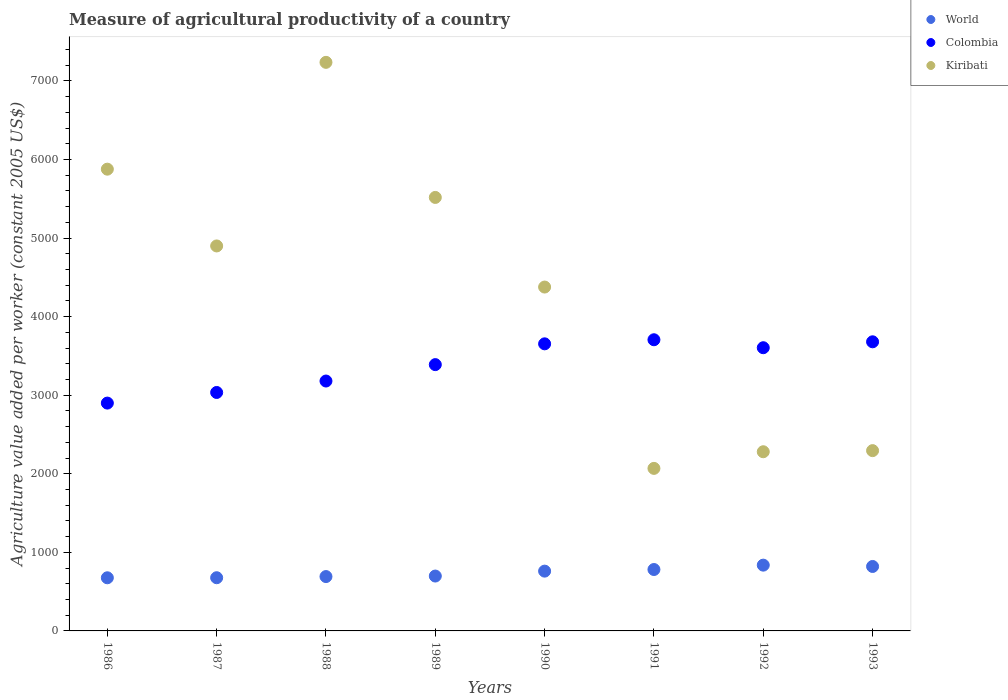What is the measure of agricultural productivity in Kiribati in 1989?
Ensure brevity in your answer.  5517.42. Across all years, what is the maximum measure of agricultural productivity in Kiribati?
Offer a terse response. 7236.76. Across all years, what is the minimum measure of agricultural productivity in World?
Provide a succinct answer. 676.35. In which year was the measure of agricultural productivity in World maximum?
Your answer should be compact. 1992. In which year was the measure of agricultural productivity in World minimum?
Offer a very short reply. 1986. What is the total measure of agricultural productivity in Colombia in the graph?
Ensure brevity in your answer.  2.71e+04. What is the difference between the measure of agricultural productivity in Colombia in 1988 and that in 1989?
Provide a succinct answer. -208.86. What is the difference between the measure of agricultural productivity in World in 1986 and the measure of agricultural productivity in Kiribati in 1987?
Offer a very short reply. -4223.58. What is the average measure of agricultural productivity in Colombia per year?
Offer a terse response. 3393.66. In the year 1987, what is the difference between the measure of agricultural productivity in Colombia and measure of agricultural productivity in World?
Provide a succinct answer. 2357.88. What is the ratio of the measure of agricultural productivity in World in 1986 to that in 1990?
Give a very brief answer. 0.89. Is the measure of agricultural productivity in Colombia in 1991 less than that in 1993?
Provide a short and direct response. No. Is the difference between the measure of agricultural productivity in Colombia in 1988 and 1989 greater than the difference between the measure of agricultural productivity in World in 1988 and 1989?
Your answer should be compact. No. What is the difference between the highest and the second highest measure of agricultural productivity in World?
Make the answer very short. 16.9. What is the difference between the highest and the lowest measure of agricultural productivity in Kiribati?
Offer a terse response. 5168.02. In how many years, is the measure of agricultural productivity in World greater than the average measure of agricultural productivity in World taken over all years?
Provide a short and direct response. 4. Does the measure of agricultural productivity in World monotonically increase over the years?
Keep it short and to the point. No. Are the values on the major ticks of Y-axis written in scientific E-notation?
Provide a short and direct response. No. Where does the legend appear in the graph?
Provide a succinct answer. Top right. How many legend labels are there?
Provide a succinct answer. 3. How are the legend labels stacked?
Your answer should be compact. Vertical. What is the title of the graph?
Provide a short and direct response. Measure of agricultural productivity of a country. Does "Guam" appear as one of the legend labels in the graph?
Your answer should be very brief. No. What is the label or title of the Y-axis?
Offer a very short reply. Agriculture value added per worker (constant 2005 US$). What is the Agriculture value added per worker (constant 2005 US$) in World in 1986?
Offer a terse response. 676.35. What is the Agriculture value added per worker (constant 2005 US$) in Colombia in 1986?
Ensure brevity in your answer.  2899.8. What is the Agriculture value added per worker (constant 2005 US$) in Kiribati in 1986?
Your response must be concise. 5877.11. What is the Agriculture value added per worker (constant 2005 US$) of World in 1987?
Provide a short and direct response. 677.1. What is the Agriculture value added per worker (constant 2005 US$) of Colombia in 1987?
Your answer should be compact. 3034.98. What is the Agriculture value added per worker (constant 2005 US$) in Kiribati in 1987?
Offer a very short reply. 4899.93. What is the Agriculture value added per worker (constant 2005 US$) of World in 1988?
Offer a very short reply. 691.86. What is the Agriculture value added per worker (constant 2005 US$) of Colombia in 1988?
Give a very brief answer. 3180.59. What is the Agriculture value added per worker (constant 2005 US$) in Kiribati in 1988?
Provide a short and direct response. 7236.76. What is the Agriculture value added per worker (constant 2005 US$) of World in 1989?
Keep it short and to the point. 698.44. What is the Agriculture value added per worker (constant 2005 US$) of Colombia in 1989?
Make the answer very short. 3389.44. What is the Agriculture value added per worker (constant 2005 US$) of Kiribati in 1989?
Your answer should be very brief. 5517.42. What is the Agriculture value added per worker (constant 2005 US$) of World in 1990?
Make the answer very short. 761.04. What is the Agriculture value added per worker (constant 2005 US$) in Colombia in 1990?
Make the answer very short. 3654.06. What is the Agriculture value added per worker (constant 2005 US$) in Kiribati in 1990?
Give a very brief answer. 4376.7. What is the Agriculture value added per worker (constant 2005 US$) of World in 1991?
Offer a very short reply. 781.57. What is the Agriculture value added per worker (constant 2005 US$) of Colombia in 1991?
Keep it short and to the point. 3705.97. What is the Agriculture value added per worker (constant 2005 US$) in Kiribati in 1991?
Provide a succinct answer. 2068.74. What is the Agriculture value added per worker (constant 2005 US$) of World in 1992?
Offer a very short reply. 837.24. What is the Agriculture value added per worker (constant 2005 US$) in Colombia in 1992?
Offer a very short reply. 3604.59. What is the Agriculture value added per worker (constant 2005 US$) in Kiribati in 1992?
Offer a terse response. 2280.57. What is the Agriculture value added per worker (constant 2005 US$) in World in 1993?
Offer a very short reply. 820.33. What is the Agriculture value added per worker (constant 2005 US$) in Colombia in 1993?
Your response must be concise. 3679.85. What is the Agriculture value added per worker (constant 2005 US$) in Kiribati in 1993?
Provide a succinct answer. 2294.68. Across all years, what is the maximum Agriculture value added per worker (constant 2005 US$) in World?
Your response must be concise. 837.24. Across all years, what is the maximum Agriculture value added per worker (constant 2005 US$) of Colombia?
Your answer should be very brief. 3705.97. Across all years, what is the maximum Agriculture value added per worker (constant 2005 US$) of Kiribati?
Offer a very short reply. 7236.76. Across all years, what is the minimum Agriculture value added per worker (constant 2005 US$) in World?
Offer a terse response. 676.35. Across all years, what is the minimum Agriculture value added per worker (constant 2005 US$) in Colombia?
Give a very brief answer. 2899.8. Across all years, what is the minimum Agriculture value added per worker (constant 2005 US$) of Kiribati?
Offer a very short reply. 2068.74. What is the total Agriculture value added per worker (constant 2005 US$) in World in the graph?
Provide a succinct answer. 5943.93. What is the total Agriculture value added per worker (constant 2005 US$) of Colombia in the graph?
Ensure brevity in your answer.  2.71e+04. What is the total Agriculture value added per worker (constant 2005 US$) of Kiribati in the graph?
Provide a succinct answer. 3.46e+04. What is the difference between the Agriculture value added per worker (constant 2005 US$) in World in 1986 and that in 1987?
Offer a very short reply. -0.75. What is the difference between the Agriculture value added per worker (constant 2005 US$) in Colombia in 1986 and that in 1987?
Provide a succinct answer. -135.18. What is the difference between the Agriculture value added per worker (constant 2005 US$) in Kiribati in 1986 and that in 1987?
Offer a terse response. 977.19. What is the difference between the Agriculture value added per worker (constant 2005 US$) in World in 1986 and that in 1988?
Your response must be concise. -15.51. What is the difference between the Agriculture value added per worker (constant 2005 US$) of Colombia in 1986 and that in 1988?
Offer a terse response. -280.79. What is the difference between the Agriculture value added per worker (constant 2005 US$) of Kiribati in 1986 and that in 1988?
Provide a short and direct response. -1359.65. What is the difference between the Agriculture value added per worker (constant 2005 US$) of World in 1986 and that in 1989?
Offer a terse response. -22.09. What is the difference between the Agriculture value added per worker (constant 2005 US$) in Colombia in 1986 and that in 1989?
Your response must be concise. -489.64. What is the difference between the Agriculture value added per worker (constant 2005 US$) of Kiribati in 1986 and that in 1989?
Your response must be concise. 359.69. What is the difference between the Agriculture value added per worker (constant 2005 US$) of World in 1986 and that in 1990?
Your response must be concise. -84.69. What is the difference between the Agriculture value added per worker (constant 2005 US$) in Colombia in 1986 and that in 1990?
Your answer should be compact. -754.26. What is the difference between the Agriculture value added per worker (constant 2005 US$) in Kiribati in 1986 and that in 1990?
Your answer should be compact. 1500.41. What is the difference between the Agriculture value added per worker (constant 2005 US$) in World in 1986 and that in 1991?
Offer a very short reply. -105.22. What is the difference between the Agriculture value added per worker (constant 2005 US$) of Colombia in 1986 and that in 1991?
Provide a short and direct response. -806.17. What is the difference between the Agriculture value added per worker (constant 2005 US$) in Kiribati in 1986 and that in 1991?
Provide a succinct answer. 3808.37. What is the difference between the Agriculture value added per worker (constant 2005 US$) in World in 1986 and that in 1992?
Provide a short and direct response. -160.89. What is the difference between the Agriculture value added per worker (constant 2005 US$) of Colombia in 1986 and that in 1992?
Give a very brief answer. -704.79. What is the difference between the Agriculture value added per worker (constant 2005 US$) of Kiribati in 1986 and that in 1992?
Offer a very short reply. 3596.54. What is the difference between the Agriculture value added per worker (constant 2005 US$) in World in 1986 and that in 1993?
Make the answer very short. -143.98. What is the difference between the Agriculture value added per worker (constant 2005 US$) of Colombia in 1986 and that in 1993?
Your response must be concise. -780.05. What is the difference between the Agriculture value added per worker (constant 2005 US$) of Kiribati in 1986 and that in 1993?
Your answer should be very brief. 3582.43. What is the difference between the Agriculture value added per worker (constant 2005 US$) in World in 1987 and that in 1988?
Keep it short and to the point. -14.76. What is the difference between the Agriculture value added per worker (constant 2005 US$) of Colombia in 1987 and that in 1988?
Your response must be concise. -145.61. What is the difference between the Agriculture value added per worker (constant 2005 US$) in Kiribati in 1987 and that in 1988?
Your answer should be compact. -2336.83. What is the difference between the Agriculture value added per worker (constant 2005 US$) of World in 1987 and that in 1989?
Your answer should be compact. -21.34. What is the difference between the Agriculture value added per worker (constant 2005 US$) of Colombia in 1987 and that in 1989?
Your answer should be compact. -354.46. What is the difference between the Agriculture value added per worker (constant 2005 US$) in Kiribati in 1987 and that in 1989?
Your response must be concise. -617.5. What is the difference between the Agriculture value added per worker (constant 2005 US$) of World in 1987 and that in 1990?
Ensure brevity in your answer.  -83.94. What is the difference between the Agriculture value added per worker (constant 2005 US$) of Colombia in 1987 and that in 1990?
Give a very brief answer. -619.08. What is the difference between the Agriculture value added per worker (constant 2005 US$) in Kiribati in 1987 and that in 1990?
Provide a short and direct response. 523.22. What is the difference between the Agriculture value added per worker (constant 2005 US$) of World in 1987 and that in 1991?
Offer a very short reply. -104.47. What is the difference between the Agriculture value added per worker (constant 2005 US$) in Colombia in 1987 and that in 1991?
Keep it short and to the point. -670.99. What is the difference between the Agriculture value added per worker (constant 2005 US$) of Kiribati in 1987 and that in 1991?
Keep it short and to the point. 2831.18. What is the difference between the Agriculture value added per worker (constant 2005 US$) in World in 1987 and that in 1992?
Your answer should be very brief. -160.14. What is the difference between the Agriculture value added per worker (constant 2005 US$) in Colombia in 1987 and that in 1992?
Your answer should be very brief. -569.61. What is the difference between the Agriculture value added per worker (constant 2005 US$) of Kiribati in 1987 and that in 1992?
Provide a succinct answer. 2619.36. What is the difference between the Agriculture value added per worker (constant 2005 US$) of World in 1987 and that in 1993?
Your response must be concise. -143.24. What is the difference between the Agriculture value added per worker (constant 2005 US$) of Colombia in 1987 and that in 1993?
Your answer should be very brief. -644.87. What is the difference between the Agriculture value added per worker (constant 2005 US$) of Kiribati in 1987 and that in 1993?
Provide a succinct answer. 2605.25. What is the difference between the Agriculture value added per worker (constant 2005 US$) of World in 1988 and that in 1989?
Your answer should be very brief. -6.58. What is the difference between the Agriculture value added per worker (constant 2005 US$) in Colombia in 1988 and that in 1989?
Keep it short and to the point. -208.86. What is the difference between the Agriculture value added per worker (constant 2005 US$) in Kiribati in 1988 and that in 1989?
Provide a succinct answer. 1719.33. What is the difference between the Agriculture value added per worker (constant 2005 US$) in World in 1988 and that in 1990?
Provide a short and direct response. -69.18. What is the difference between the Agriculture value added per worker (constant 2005 US$) in Colombia in 1988 and that in 1990?
Your response must be concise. -473.48. What is the difference between the Agriculture value added per worker (constant 2005 US$) in Kiribati in 1988 and that in 1990?
Keep it short and to the point. 2860.06. What is the difference between the Agriculture value added per worker (constant 2005 US$) of World in 1988 and that in 1991?
Your answer should be compact. -89.71. What is the difference between the Agriculture value added per worker (constant 2005 US$) of Colombia in 1988 and that in 1991?
Keep it short and to the point. -525.39. What is the difference between the Agriculture value added per worker (constant 2005 US$) in Kiribati in 1988 and that in 1991?
Provide a succinct answer. 5168.02. What is the difference between the Agriculture value added per worker (constant 2005 US$) of World in 1988 and that in 1992?
Your response must be concise. -145.38. What is the difference between the Agriculture value added per worker (constant 2005 US$) in Colombia in 1988 and that in 1992?
Keep it short and to the point. -424. What is the difference between the Agriculture value added per worker (constant 2005 US$) of Kiribati in 1988 and that in 1992?
Your answer should be very brief. 4956.19. What is the difference between the Agriculture value added per worker (constant 2005 US$) in World in 1988 and that in 1993?
Ensure brevity in your answer.  -128.47. What is the difference between the Agriculture value added per worker (constant 2005 US$) in Colombia in 1988 and that in 1993?
Provide a short and direct response. -499.26. What is the difference between the Agriculture value added per worker (constant 2005 US$) of Kiribati in 1988 and that in 1993?
Provide a succinct answer. 4942.08. What is the difference between the Agriculture value added per worker (constant 2005 US$) in World in 1989 and that in 1990?
Your answer should be compact. -62.6. What is the difference between the Agriculture value added per worker (constant 2005 US$) in Colombia in 1989 and that in 1990?
Offer a terse response. -264.62. What is the difference between the Agriculture value added per worker (constant 2005 US$) of Kiribati in 1989 and that in 1990?
Offer a terse response. 1140.72. What is the difference between the Agriculture value added per worker (constant 2005 US$) of World in 1989 and that in 1991?
Provide a succinct answer. -83.13. What is the difference between the Agriculture value added per worker (constant 2005 US$) of Colombia in 1989 and that in 1991?
Your answer should be very brief. -316.53. What is the difference between the Agriculture value added per worker (constant 2005 US$) of Kiribati in 1989 and that in 1991?
Give a very brief answer. 3448.68. What is the difference between the Agriculture value added per worker (constant 2005 US$) in World in 1989 and that in 1992?
Your answer should be very brief. -138.8. What is the difference between the Agriculture value added per worker (constant 2005 US$) in Colombia in 1989 and that in 1992?
Provide a succinct answer. -215.14. What is the difference between the Agriculture value added per worker (constant 2005 US$) of Kiribati in 1989 and that in 1992?
Offer a very short reply. 3236.86. What is the difference between the Agriculture value added per worker (constant 2005 US$) of World in 1989 and that in 1993?
Make the answer very short. -121.89. What is the difference between the Agriculture value added per worker (constant 2005 US$) in Colombia in 1989 and that in 1993?
Provide a short and direct response. -290.4. What is the difference between the Agriculture value added per worker (constant 2005 US$) in Kiribati in 1989 and that in 1993?
Provide a short and direct response. 3222.75. What is the difference between the Agriculture value added per worker (constant 2005 US$) in World in 1990 and that in 1991?
Offer a very short reply. -20.53. What is the difference between the Agriculture value added per worker (constant 2005 US$) of Colombia in 1990 and that in 1991?
Provide a succinct answer. -51.91. What is the difference between the Agriculture value added per worker (constant 2005 US$) in Kiribati in 1990 and that in 1991?
Make the answer very short. 2307.96. What is the difference between the Agriculture value added per worker (constant 2005 US$) in World in 1990 and that in 1992?
Ensure brevity in your answer.  -76.2. What is the difference between the Agriculture value added per worker (constant 2005 US$) of Colombia in 1990 and that in 1992?
Make the answer very short. 49.47. What is the difference between the Agriculture value added per worker (constant 2005 US$) in Kiribati in 1990 and that in 1992?
Keep it short and to the point. 2096.13. What is the difference between the Agriculture value added per worker (constant 2005 US$) in World in 1990 and that in 1993?
Ensure brevity in your answer.  -59.29. What is the difference between the Agriculture value added per worker (constant 2005 US$) of Colombia in 1990 and that in 1993?
Keep it short and to the point. -25.79. What is the difference between the Agriculture value added per worker (constant 2005 US$) in Kiribati in 1990 and that in 1993?
Your answer should be very brief. 2082.02. What is the difference between the Agriculture value added per worker (constant 2005 US$) in World in 1991 and that in 1992?
Give a very brief answer. -55.67. What is the difference between the Agriculture value added per worker (constant 2005 US$) in Colombia in 1991 and that in 1992?
Your answer should be very brief. 101.38. What is the difference between the Agriculture value added per worker (constant 2005 US$) in Kiribati in 1991 and that in 1992?
Provide a succinct answer. -211.83. What is the difference between the Agriculture value added per worker (constant 2005 US$) of World in 1991 and that in 1993?
Make the answer very short. -38.76. What is the difference between the Agriculture value added per worker (constant 2005 US$) of Colombia in 1991 and that in 1993?
Your answer should be very brief. 26.13. What is the difference between the Agriculture value added per worker (constant 2005 US$) of Kiribati in 1991 and that in 1993?
Provide a succinct answer. -225.94. What is the difference between the Agriculture value added per worker (constant 2005 US$) of World in 1992 and that in 1993?
Give a very brief answer. 16.9. What is the difference between the Agriculture value added per worker (constant 2005 US$) in Colombia in 1992 and that in 1993?
Offer a very short reply. -75.26. What is the difference between the Agriculture value added per worker (constant 2005 US$) of Kiribati in 1992 and that in 1993?
Provide a short and direct response. -14.11. What is the difference between the Agriculture value added per worker (constant 2005 US$) in World in 1986 and the Agriculture value added per worker (constant 2005 US$) in Colombia in 1987?
Your answer should be compact. -2358.63. What is the difference between the Agriculture value added per worker (constant 2005 US$) of World in 1986 and the Agriculture value added per worker (constant 2005 US$) of Kiribati in 1987?
Your answer should be very brief. -4223.58. What is the difference between the Agriculture value added per worker (constant 2005 US$) of Colombia in 1986 and the Agriculture value added per worker (constant 2005 US$) of Kiribati in 1987?
Offer a terse response. -2000.13. What is the difference between the Agriculture value added per worker (constant 2005 US$) in World in 1986 and the Agriculture value added per worker (constant 2005 US$) in Colombia in 1988?
Your response must be concise. -2504.24. What is the difference between the Agriculture value added per worker (constant 2005 US$) of World in 1986 and the Agriculture value added per worker (constant 2005 US$) of Kiribati in 1988?
Keep it short and to the point. -6560.41. What is the difference between the Agriculture value added per worker (constant 2005 US$) of Colombia in 1986 and the Agriculture value added per worker (constant 2005 US$) of Kiribati in 1988?
Your answer should be compact. -4336.96. What is the difference between the Agriculture value added per worker (constant 2005 US$) in World in 1986 and the Agriculture value added per worker (constant 2005 US$) in Colombia in 1989?
Provide a succinct answer. -2713.09. What is the difference between the Agriculture value added per worker (constant 2005 US$) of World in 1986 and the Agriculture value added per worker (constant 2005 US$) of Kiribati in 1989?
Make the answer very short. -4841.07. What is the difference between the Agriculture value added per worker (constant 2005 US$) of Colombia in 1986 and the Agriculture value added per worker (constant 2005 US$) of Kiribati in 1989?
Keep it short and to the point. -2617.62. What is the difference between the Agriculture value added per worker (constant 2005 US$) of World in 1986 and the Agriculture value added per worker (constant 2005 US$) of Colombia in 1990?
Your answer should be very brief. -2977.71. What is the difference between the Agriculture value added per worker (constant 2005 US$) in World in 1986 and the Agriculture value added per worker (constant 2005 US$) in Kiribati in 1990?
Offer a very short reply. -3700.35. What is the difference between the Agriculture value added per worker (constant 2005 US$) of Colombia in 1986 and the Agriculture value added per worker (constant 2005 US$) of Kiribati in 1990?
Make the answer very short. -1476.9. What is the difference between the Agriculture value added per worker (constant 2005 US$) in World in 1986 and the Agriculture value added per worker (constant 2005 US$) in Colombia in 1991?
Provide a succinct answer. -3029.62. What is the difference between the Agriculture value added per worker (constant 2005 US$) of World in 1986 and the Agriculture value added per worker (constant 2005 US$) of Kiribati in 1991?
Your response must be concise. -1392.39. What is the difference between the Agriculture value added per worker (constant 2005 US$) of Colombia in 1986 and the Agriculture value added per worker (constant 2005 US$) of Kiribati in 1991?
Make the answer very short. 831.06. What is the difference between the Agriculture value added per worker (constant 2005 US$) of World in 1986 and the Agriculture value added per worker (constant 2005 US$) of Colombia in 1992?
Your response must be concise. -2928.24. What is the difference between the Agriculture value added per worker (constant 2005 US$) of World in 1986 and the Agriculture value added per worker (constant 2005 US$) of Kiribati in 1992?
Your response must be concise. -1604.22. What is the difference between the Agriculture value added per worker (constant 2005 US$) in Colombia in 1986 and the Agriculture value added per worker (constant 2005 US$) in Kiribati in 1992?
Your response must be concise. 619.23. What is the difference between the Agriculture value added per worker (constant 2005 US$) of World in 1986 and the Agriculture value added per worker (constant 2005 US$) of Colombia in 1993?
Give a very brief answer. -3003.5. What is the difference between the Agriculture value added per worker (constant 2005 US$) in World in 1986 and the Agriculture value added per worker (constant 2005 US$) in Kiribati in 1993?
Provide a succinct answer. -1618.33. What is the difference between the Agriculture value added per worker (constant 2005 US$) in Colombia in 1986 and the Agriculture value added per worker (constant 2005 US$) in Kiribati in 1993?
Provide a short and direct response. 605.12. What is the difference between the Agriculture value added per worker (constant 2005 US$) of World in 1987 and the Agriculture value added per worker (constant 2005 US$) of Colombia in 1988?
Your answer should be compact. -2503.49. What is the difference between the Agriculture value added per worker (constant 2005 US$) in World in 1987 and the Agriculture value added per worker (constant 2005 US$) in Kiribati in 1988?
Provide a succinct answer. -6559.66. What is the difference between the Agriculture value added per worker (constant 2005 US$) in Colombia in 1987 and the Agriculture value added per worker (constant 2005 US$) in Kiribati in 1988?
Offer a very short reply. -4201.78. What is the difference between the Agriculture value added per worker (constant 2005 US$) of World in 1987 and the Agriculture value added per worker (constant 2005 US$) of Colombia in 1989?
Give a very brief answer. -2712.35. What is the difference between the Agriculture value added per worker (constant 2005 US$) in World in 1987 and the Agriculture value added per worker (constant 2005 US$) in Kiribati in 1989?
Give a very brief answer. -4840.33. What is the difference between the Agriculture value added per worker (constant 2005 US$) of Colombia in 1987 and the Agriculture value added per worker (constant 2005 US$) of Kiribati in 1989?
Offer a terse response. -2482.44. What is the difference between the Agriculture value added per worker (constant 2005 US$) in World in 1987 and the Agriculture value added per worker (constant 2005 US$) in Colombia in 1990?
Provide a succinct answer. -2976.97. What is the difference between the Agriculture value added per worker (constant 2005 US$) in World in 1987 and the Agriculture value added per worker (constant 2005 US$) in Kiribati in 1990?
Give a very brief answer. -3699.61. What is the difference between the Agriculture value added per worker (constant 2005 US$) of Colombia in 1987 and the Agriculture value added per worker (constant 2005 US$) of Kiribati in 1990?
Provide a succinct answer. -1341.72. What is the difference between the Agriculture value added per worker (constant 2005 US$) in World in 1987 and the Agriculture value added per worker (constant 2005 US$) in Colombia in 1991?
Make the answer very short. -3028.88. What is the difference between the Agriculture value added per worker (constant 2005 US$) in World in 1987 and the Agriculture value added per worker (constant 2005 US$) in Kiribati in 1991?
Your answer should be compact. -1391.65. What is the difference between the Agriculture value added per worker (constant 2005 US$) of Colombia in 1987 and the Agriculture value added per worker (constant 2005 US$) of Kiribati in 1991?
Offer a terse response. 966.24. What is the difference between the Agriculture value added per worker (constant 2005 US$) of World in 1987 and the Agriculture value added per worker (constant 2005 US$) of Colombia in 1992?
Make the answer very short. -2927.49. What is the difference between the Agriculture value added per worker (constant 2005 US$) in World in 1987 and the Agriculture value added per worker (constant 2005 US$) in Kiribati in 1992?
Your response must be concise. -1603.47. What is the difference between the Agriculture value added per worker (constant 2005 US$) of Colombia in 1987 and the Agriculture value added per worker (constant 2005 US$) of Kiribati in 1992?
Offer a very short reply. 754.41. What is the difference between the Agriculture value added per worker (constant 2005 US$) in World in 1987 and the Agriculture value added per worker (constant 2005 US$) in Colombia in 1993?
Make the answer very short. -3002.75. What is the difference between the Agriculture value added per worker (constant 2005 US$) of World in 1987 and the Agriculture value added per worker (constant 2005 US$) of Kiribati in 1993?
Keep it short and to the point. -1617.58. What is the difference between the Agriculture value added per worker (constant 2005 US$) in Colombia in 1987 and the Agriculture value added per worker (constant 2005 US$) in Kiribati in 1993?
Ensure brevity in your answer.  740.3. What is the difference between the Agriculture value added per worker (constant 2005 US$) of World in 1988 and the Agriculture value added per worker (constant 2005 US$) of Colombia in 1989?
Offer a very short reply. -2697.59. What is the difference between the Agriculture value added per worker (constant 2005 US$) in World in 1988 and the Agriculture value added per worker (constant 2005 US$) in Kiribati in 1989?
Your response must be concise. -4825.57. What is the difference between the Agriculture value added per worker (constant 2005 US$) in Colombia in 1988 and the Agriculture value added per worker (constant 2005 US$) in Kiribati in 1989?
Provide a succinct answer. -2336.84. What is the difference between the Agriculture value added per worker (constant 2005 US$) of World in 1988 and the Agriculture value added per worker (constant 2005 US$) of Colombia in 1990?
Your answer should be very brief. -2962.2. What is the difference between the Agriculture value added per worker (constant 2005 US$) in World in 1988 and the Agriculture value added per worker (constant 2005 US$) in Kiribati in 1990?
Ensure brevity in your answer.  -3684.84. What is the difference between the Agriculture value added per worker (constant 2005 US$) of Colombia in 1988 and the Agriculture value added per worker (constant 2005 US$) of Kiribati in 1990?
Offer a very short reply. -1196.12. What is the difference between the Agriculture value added per worker (constant 2005 US$) in World in 1988 and the Agriculture value added per worker (constant 2005 US$) in Colombia in 1991?
Offer a terse response. -3014.11. What is the difference between the Agriculture value added per worker (constant 2005 US$) of World in 1988 and the Agriculture value added per worker (constant 2005 US$) of Kiribati in 1991?
Make the answer very short. -1376.88. What is the difference between the Agriculture value added per worker (constant 2005 US$) in Colombia in 1988 and the Agriculture value added per worker (constant 2005 US$) in Kiribati in 1991?
Your answer should be compact. 1111.84. What is the difference between the Agriculture value added per worker (constant 2005 US$) of World in 1988 and the Agriculture value added per worker (constant 2005 US$) of Colombia in 1992?
Your response must be concise. -2912.73. What is the difference between the Agriculture value added per worker (constant 2005 US$) in World in 1988 and the Agriculture value added per worker (constant 2005 US$) in Kiribati in 1992?
Your answer should be very brief. -1588.71. What is the difference between the Agriculture value added per worker (constant 2005 US$) of Colombia in 1988 and the Agriculture value added per worker (constant 2005 US$) of Kiribati in 1992?
Your response must be concise. 900.02. What is the difference between the Agriculture value added per worker (constant 2005 US$) in World in 1988 and the Agriculture value added per worker (constant 2005 US$) in Colombia in 1993?
Offer a very short reply. -2987.99. What is the difference between the Agriculture value added per worker (constant 2005 US$) in World in 1988 and the Agriculture value added per worker (constant 2005 US$) in Kiribati in 1993?
Provide a short and direct response. -1602.82. What is the difference between the Agriculture value added per worker (constant 2005 US$) of Colombia in 1988 and the Agriculture value added per worker (constant 2005 US$) of Kiribati in 1993?
Your answer should be compact. 885.91. What is the difference between the Agriculture value added per worker (constant 2005 US$) of World in 1989 and the Agriculture value added per worker (constant 2005 US$) of Colombia in 1990?
Make the answer very short. -2955.62. What is the difference between the Agriculture value added per worker (constant 2005 US$) of World in 1989 and the Agriculture value added per worker (constant 2005 US$) of Kiribati in 1990?
Keep it short and to the point. -3678.26. What is the difference between the Agriculture value added per worker (constant 2005 US$) in Colombia in 1989 and the Agriculture value added per worker (constant 2005 US$) in Kiribati in 1990?
Ensure brevity in your answer.  -987.26. What is the difference between the Agriculture value added per worker (constant 2005 US$) in World in 1989 and the Agriculture value added per worker (constant 2005 US$) in Colombia in 1991?
Your answer should be very brief. -3007.53. What is the difference between the Agriculture value added per worker (constant 2005 US$) in World in 1989 and the Agriculture value added per worker (constant 2005 US$) in Kiribati in 1991?
Provide a succinct answer. -1370.3. What is the difference between the Agriculture value added per worker (constant 2005 US$) in Colombia in 1989 and the Agriculture value added per worker (constant 2005 US$) in Kiribati in 1991?
Offer a very short reply. 1320.7. What is the difference between the Agriculture value added per worker (constant 2005 US$) in World in 1989 and the Agriculture value added per worker (constant 2005 US$) in Colombia in 1992?
Keep it short and to the point. -2906.15. What is the difference between the Agriculture value added per worker (constant 2005 US$) in World in 1989 and the Agriculture value added per worker (constant 2005 US$) in Kiribati in 1992?
Provide a short and direct response. -1582.13. What is the difference between the Agriculture value added per worker (constant 2005 US$) of Colombia in 1989 and the Agriculture value added per worker (constant 2005 US$) of Kiribati in 1992?
Your response must be concise. 1108.88. What is the difference between the Agriculture value added per worker (constant 2005 US$) in World in 1989 and the Agriculture value added per worker (constant 2005 US$) in Colombia in 1993?
Your answer should be very brief. -2981.41. What is the difference between the Agriculture value added per worker (constant 2005 US$) in World in 1989 and the Agriculture value added per worker (constant 2005 US$) in Kiribati in 1993?
Keep it short and to the point. -1596.24. What is the difference between the Agriculture value added per worker (constant 2005 US$) of Colombia in 1989 and the Agriculture value added per worker (constant 2005 US$) of Kiribati in 1993?
Your response must be concise. 1094.77. What is the difference between the Agriculture value added per worker (constant 2005 US$) in World in 1990 and the Agriculture value added per worker (constant 2005 US$) in Colombia in 1991?
Provide a short and direct response. -2944.93. What is the difference between the Agriculture value added per worker (constant 2005 US$) of World in 1990 and the Agriculture value added per worker (constant 2005 US$) of Kiribati in 1991?
Your answer should be very brief. -1307.7. What is the difference between the Agriculture value added per worker (constant 2005 US$) in Colombia in 1990 and the Agriculture value added per worker (constant 2005 US$) in Kiribati in 1991?
Your response must be concise. 1585.32. What is the difference between the Agriculture value added per worker (constant 2005 US$) of World in 1990 and the Agriculture value added per worker (constant 2005 US$) of Colombia in 1992?
Your response must be concise. -2843.55. What is the difference between the Agriculture value added per worker (constant 2005 US$) of World in 1990 and the Agriculture value added per worker (constant 2005 US$) of Kiribati in 1992?
Provide a short and direct response. -1519.53. What is the difference between the Agriculture value added per worker (constant 2005 US$) in Colombia in 1990 and the Agriculture value added per worker (constant 2005 US$) in Kiribati in 1992?
Provide a succinct answer. 1373.49. What is the difference between the Agriculture value added per worker (constant 2005 US$) in World in 1990 and the Agriculture value added per worker (constant 2005 US$) in Colombia in 1993?
Your answer should be compact. -2918.81. What is the difference between the Agriculture value added per worker (constant 2005 US$) in World in 1990 and the Agriculture value added per worker (constant 2005 US$) in Kiribati in 1993?
Your response must be concise. -1533.64. What is the difference between the Agriculture value added per worker (constant 2005 US$) in Colombia in 1990 and the Agriculture value added per worker (constant 2005 US$) in Kiribati in 1993?
Your answer should be compact. 1359.38. What is the difference between the Agriculture value added per worker (constant 2005 US$) in World in 1991 and the Agriculture value added per worker (constant 2005 US$) in Colombia in 1992?
Your response must be concise. -2823.02. What is the difference between the Agriculture value added per worker (constant 2005 US$) of World in 1991 and the Agriculture value added per worker (constant 2005 US$) of Kiribati in 1992?
Your answer should be very brief. -1499. What is the difference between the Agriculture value added per worker (constant 2005 US$) in Colombia in 1991 and the Agriculture value added per worker (constant 2005 US$) in Kiribati in 1992?
Provide a succinct answer. 1425.4. What is the difference between the Agriculture value added per worker (constant 2005 US$) in World in 1991 and the Agriculture value added per worker (constant 2005 US$) in Colombia in 1993?
Keep it short and to the point. -2898.28. What is the difference between the Agriculture value added per worker (constant 2005 US$) in World in 1991 and the Agriculture value added per worker (constant 2005 US$) in Kiribati in 1993?
Offer a terse response. -1513.11. What is the difference between the Agriculture value added per worker (constant 2005 US$) in Colombia in 1991 and the Agriculture value added per worker (constant 2005 US$) in Kiribati in 1993?
Make the answer very short. 1411.3. What is the difference between the Agriculture value added per worker (constant 2005 US$) of World in 1992 and the Agriculture value added per worker (constant 2005 US$) of Colombia in 1993?
Ensure brevity in your answer.  -2842.61. What is the difference between the Agriculture value added per worker (constant 2005 US$) of World in 1992 and the Agriculture value added per worker (constant 2005 US$) of Kiribati in 1993?
Provide a succinct answer. -1457.44. What is the difference between the Agriculture value added per worker (constant 2005 US$) in Colombia in 1992 and the Agriculture value added per worker (constant 2005 US$) in Kiribati in 1993?
Your response must be concise. 1309.91. What is the average Agriculture value added per worker (constant 2005 US$) in World per year?
Offer a very short reply. 742.99. What is the average Agriculture value added per worker (constant 2005 US$) in Colombia per year?
Your answer should be compact. 3393.66. What is the average Agriculture value added per worker (constant 2005 US$) of Kiribati per year?
Keep it short and to the point. 4318.99. In the year 1986, what is the difference between the Agriculture value added per worker (constant 2005 US$) of World and Agriculture value added per worker (constant 2005 US$) of Colombia?
Provide a succinct answer. -2223.45. In the year 1986, what is the difference between the Agriculture value added per worker (constant 2005 US$) of World and Agriculture value added per worker (constant 2005 US$) of Kiribati?
Offer a very short reply. -5200.76. In the year 1986, what is the difference between the Agriculture value added per worker (constant 2005 US$) of Colombia and Agriculture value added per worker (constant 2005 US$) of Kiribati?
Provide a succinct answer. -2977.31. In the year 1987, what is the difference between the Agriculture value added per worker (constant 2005 US$) in World and Agriculture value added per worker (constant 2005 US$) in Colombia?
Make the answer very short. -2357.88. In the year 1987, what is the difference between the Agriculture value added per worker (constant 2005 US$) in World and Agriculture value added per worker (constant 2005 US$) in Kiribati?
Offer a terse response. -4222.83. In the year 1987, what is the difference between the Agriculture value added per worker (constant 2005 US$) in Colombia and Agriculture value added per worker (constant 2005 US$) in Kiribati?
Provide a short and direct response. -1864.94. In the year 1988, what is the difference between the Agriculture value added per worker (constant 2005 US$) in World and Agriculture value added per worker (constant 2005 US$) in Colombia?
Offer a very short reply. -2488.73. In the year 1988, what is the difference between the Agriculture value added per worker (constant 2005 US$) in World and Agriculture value added per worker (constant 2005 US$) in Kiribati?
Keep it short and to the point. -6544.9. In the year 1988, what is the difference between the Agriculture value added per worker (constant 2005 US$) of Colombia and Agriculture value added per worker (constant 2005 US$) of Kiribati?
Keep it short and to the point. -4056.17. In the year 1989, what is the difference between the Agriculture value added per worker (constant 2005 US$) in World and Agriculture value added per worker (constant 2005 US$) in Colombia?
Offer a very short reply. -2691. In the year 1989, what is the difference between the Agriculture value added per worker (constant 2005 US$) of World and Agriculture value added per worker (constant 2005 US$) of Kiribati?
Offer a very short reply. -4818.98. In the year 1989, what is the difference between the Agriculture value added per worker (constant 2005 US$) of Colombia and Agriculture value added per worker (constant 2005 US$) of Kiribati?
Ensure brevity in your answer.  -2127.98. In the year 1990, what is the difference between the Agriculture value added per worker (constant 2005 US$) in World and Agriculture value added per worker (constant 2005 US$) in Colombia?
Provide a short and direct response. -2893.02. In the year 1990, what is the difference between the Agriculture value added per worker (constant 2005 US$) in World and Agriculture value added per worker (constant 2005 US$) in Kiribati?
Ensure brevity in your answer.  -3615.66. In the year 1990, what is the difference between the Agriculture value added per worker (constant 2005 US$) of Colombia and Agriculture value added per worker (constant 2005 US$) of Kiribati?
Keep it short and to the point. -722.64. In the year 1991, what is the difference between the Agriculture value added per worker (constant 2005 US$) in World and Agriculture value added per worker (constant 2005 US$) in Colombia?
Offer a very short reply. -2924.4. In the year 1991, what is the difference between the Agriculture value added per worker (constant 2005 US$) in World and Agriculture value added per worker (constant 2005 US$) in Kiribati?
Offer a very short reply. -1287.17. In the year 1991, what is the difference between the Agriculture value added per worker (constant 2005 US$) in Colombia and Agriculture value added per worker (constant 2005 US$) in Kiribati?
Your response must be concise. 1637.23. In the year 1992, what is the difference between the Agriculture value added per worker (constant 2005 US$) in World and Agriculture value added per worker (constant 2005 US$) in Colombia?
Your answer should be compact. -2767.35. In the year 1992, what is the difference between the Agriculture value added per worker (constant 2005 US$) of World and Agriculture value added per worker (constant 2005 US$) of Kiribati?
Offer a very short reply. -1443.33. In the year 1992, what is the difference between the Agriculture value added per worker (constant 2005 US$) of Colombia and Agriculture value added per worker (constant 2005 US$) of Kiribati?
Make the answer very short. 1324.02. In the year 1993, what is the difference between the Agriculture value added per worker (constant 2005 US$) in World and Agriculture value added per worker (constant 2005 US$) in Colombia?
Your answer should be very brief. -2859.51. In the year 1993, what is the difference between the Agriculture value added per worker (constant 2005 US$) of World and Agriculture value added per worker (constant 2005 US$) of Kiribati?
Offer a terse response. -1474.34. In the year 1993, what is the difference between the Agriculture value added per worker (constant 2005 US$) of Colombia and Agriculture value added per worker (constant 2005 US$) of Kiribati?
Keep it short and to the point. 1385.17. What is the ratio of the Agriculture value added per worker (constant 2005 US$) in Colombia in 1986 to that in 1987?
Your answer should be very brief. 0.96. What is the ratio of the Agriculture value added per worker (constant 2005 US$) of Kiribati in 1986 to that in 1987?
Provide a succinct answer. 1.2. What is the ratio of the Agriculture value added per worker (constant 2005 US$) of World in 1986 to that in 1988?
Ensure brevity in your answer.  0.98. What is the ratio of the Agriculture value added per worker (constant 2005 US$) in Colombia in 1986 to that in 1988?
Keep it short and to the point. 0.91. What is the ratio of the Agriculture value added per worker (constant 2005 US$) of Kiribati in 1986 to that in 1988?
Your response must be concise. 0.81. What is the ratio of the Agriculture value added per worker (constant 2005 US$) in World in 1986 to that in 1989?
Provide a succinct answer. 0.97. What is the ratio of the Agriculture value added per worker (constant 2005 US$) in Colombia in 1986 to that in 1989?
Your response must be concise. 0.86. What is the ratio of the Agriculture value added per worker (constant 2005 US$) in Kiribati in 1986 to that in 1989?
Give a very brief answer. 1.07. What is the ratio of the Agriculture value added per worker (constant 2005 US$) of World in 1986 to that in 1990?
Give a very brief answer. 0.89. What is the ratio of the Agriculture value added per worker (constant 2005 US$) in Colombia in 1986 to that in 1990?
Give a very brief answer. 0.79. What is the ratio of the Agriculture value added per worker (constant 2005 US$) in Kiribati in 1986 to that in 1990?
Your answer should be very brief. 1.34. What is the ratio of the Agriculture value added per worker (constant 2005 US$) in World in 1986 to that in 1991?
Offer a terse response. 0.87. What is the ratio of the Agriculture value added per worker (constant 2005 US$) of Colombia in 1986 to that in 1991?
Keep it short and to the point. 0.78. What is the ratio of the Agriculture value added per worker (constant 2005 US$) in Kiribati in 1986 to that in 1991?
Your answer should be very brief. 2.84. What is the ratio of the Agriculture value added per worker (constant 2005 US$) of World in 1986 to that in 1992?
Your answer should be very brief. 0.81. What is the ratio of the Agriculture value added per worker (constant 2005 US$) in Colombia in 1986 to that in 1992?
Provide a succinct answer. 0.8. What is the ratio of the Agriculture value added per worker (constant 2005 US$) of Kiribati in 1986 to that in 1992?
Your response must be concise. 2.58. What is the ratio of the Agriculture value added per worker (constant 2005 US$) of World in 1986 to that in 1993?
Your response must be concise. 0.82. What is the ratio of the Agriculture value added per worker (constant 2005 US$) of Colombia in 1986 to that in 1993?
Ensure brevity in your answer.  0.79. What is the ratio of the Agriculture value added per worker (constant 2005 US$) in Kiribati in 1986 to that in 1993?
Your answer should be very brief. 2.56. What is the ratio of the Agriculture value added per worker (constant 2005 US$) in World in 1987 to that in 1988?
Ensure brevity in your answer.  0.98. What is the ratio of the Agriculture value added per worker (constant 2005 US$) in Colombia in 1987 to that in 1988?
Your response must be concise. 0.95. What is the ratio of the Agriculture value added per worker (constant 2005 US$) of Kiribati in 1987 to that in 1988?
Your answer should be very brief. 0.68. What is the ratio of the Agriculture value added per worker (constant 2005 US$) in World in 1987 to that in 1989?
Make the answer very short. 0.97. What is the ratio of the Agriculture value added per worker (constant 2005 US$) in Colombia in 1987 to that in 1989?
Your answer should be compact. 0.9. What is the ratio of the Agriculture value added per worker (constant 2005 US$) of Kiribati in 1987 to that in 1989?
Provide a short and direct response. 0.89. What is the ratio of the Agriculture value added per worker (constant 2005 US$) in World in 1987 to that in 1990?
Your answer should be compact. 0.89. What is the ratio of the Agriculture value added per worker (constant 2005 US$) of Colombia in 1987 to that in 1990?
Make the answer very short. 0.83. What is the ratio of the Agriculture value added per worker (constant 2005 US$) in Kiribati in 1987 to that in 1990?
Offer a very short reply. 1.12. What is the ratio of the Agriculture value added per worker (constant 2005 US$) in World in 1987 to that in 1991?
Give a very brief answer. 0.87. What is the ratio of the Agriculture value added per worker (constant 2005 US$) of Colombia in 1987 to that in 1991?
Offer a very short reply. 0.82. What is the ratio of the Agriculture value added per worker (constant 2005 US$) of Kiribati in 1987 to that in 1991?
Your answer should be very brief. 2.37. What is the ratio of the Agriculture value added per worker (constant 2005 US$) in World in 1987 to that in 1992?
Offer a terse response. 0.81. What is the ratio of the Agriculture value added per worker (constant 2005 US$) in Colombia in 1987 to that in 1992?
Make the answer very short. 0.84. What is the ratio of the Agriculture value added per worker (constant 2005 US$) in Kiribati in 1987 to that in 1992?
Make the answer very short. 2.15. What is the ratio of the Agriculture value added per worker (constant 2005 US$) of World in 1987 to that in 1993?
Offer a very short reply. 0.83. What is the ratio of the Agriculture value added per worker (constant 2005 US$) of Colombia in 1987 to that in 1993?
Your answer should be compact. 0.82. What is the ratio of the Agriculture value added per worker (constant 2005 US$) of Kiribati in 1987 to that in 1993?
Your answer should be compact. 2.14. What is the ratio of the Agriculture value added per worker (constant 2005 US$) in World in 1988 to that in 1989?
Make the answer very short. 0.99. What is the ratio of the Agriculture value added per worker (constant 2005 US$) in Colombia in 1988 to that in 1989?
Your answer should be very brief. 0.94. What is the ratio of the Agriculture value added per worker (constant 2005 US$) of Kiribati in 1988 to that in 1989?
Your answer should be very brief. 1.31. What is the ratio of the Agriculture value added per worker (constant 2005 US$) in World in 1988 to that in 1990?
Offer a terse response. 0.91. What is the ratio of the Agriculture value added per worker (constant 2005 US$) in Colombia in 1988 to that in 1990?
Offer a very short reply. 0.87. What is the ratio of the Agriculture value added per worker (constant 2005 US$) of Kiribati in 1988 to that in 1990?
Your response must be concise. 1.65. What is the ratio of the Agriculture value added per worker (constant 2005 US$) in World in 1988 to that in 1991?
Your answer should be very brief. 0.89. What is the ratio of the Agriculture value added per worker (constant 2005 US$) in Colombia in 1988 to that in 1991?
Your answer should be compact. 0.86. What is the ratio of the Agriculture value added per worker (constant 2005 US$) in Kiribati in 1988 to that in 1991?
Provide a succinct answer. 3.5. What is the ratio of the Agriculture value added per worker (constant 2005 US$) in World in 1988 to that in 1992?
Keep it short and to the point. 0.83. What is the ratio of the Agriculture value added per worker (constant 2005 US$) in Colombia in 1988 to that in 1992?
Ensure brevity in your answer.  0.88. What is the ratio of the Agriculture value added per worker (constant 2005 US$) in Kiribati in 1988 to that in 1992?
Make the answer very short. 3.17. What is the ratio of the Agriculture value added per worker (constant 2005 US$) in World in 1988 to that in 1993?
Your answer should be compact. 0.84. What is the ratio of the Agriculture value added per worker (constant 2005 US$) in Colombia in 1988 to that in 1993?
Provide a short and direct response. 0.86. What is the ratio of the Agriculture value added per worker (constant 2005 US$) in Kiribati in 1988 to that in 1993?
Provide a succinct answer. 3.15. What is the ratio of the Agriculture value added per worker (constant 2005 US$) in World in 1989 to that in 1990?
Keep it short and to the point. 0.92. What is the ratio of the Agriculture value added per worker (constant 2005 US$) of Colombia in 1989 to that in 1990?
Ensure brevity in your answer.  0.93. What is the ratio of the Agriculture value added per worker (constant 2005 US$) in Kiribati in 1989 to that in 1990?
Make the answer very short. 1.26. What is the ratio of the Agriculture value added per worker (constant 2005 US$) in World in 1989 to that in 1991?
Your response must be concise. 0.89. What is the ratio of the Agriculture value added per worker (constant 2005 US$) in Colombia in 1989 to that in 1991?
Ensure brevity in your answer.  0.91. What is the ratio of the Agriculture value added per worker (constant 2005 US$) in Kiribati in 1989 to that in 1991?
Your answer should be very brief. 2.67. What is the ratio of the Agriculture value added per worker (constant 2005 US$) of World in 1989 to that in 1992?
Keep it short and to the point. 0.83. What is the ratio of the Agriculture value added per worker (constant 2005 US$) of Colombia in 1989 to that in 1992?
Offer a terse response. 0.94. What is the ratio of the Agriculture value added per worker (constant 2005 US$) in Kiribati in 1989 to that in 1992?
Give a very brief answer. 2.42. What is the ratio of the Agriculture value added per worker (constant 2005 US$) in World in 1989 to that in 1993?
Your answer should be compact. 0.85. What is the ratio of the Agriculture value added per worker (constant 2005 US$) in Colombia in 1989 to that in 1993?
Make the answer very short. 0.92. What is the ratio of the Agriculture value added per worker (constant 2005 US$) in Kiribati in 1989 to that in 1993?
Provide a succinct answer. 2.4. What is the ratio of the Agriculture value added per worker (constant 2005 US$) of World in 1990 to that in 1991?
Provide a short and direct response. 0.97. What is the ratio of the Agriculture value added per worker (constant 2005 US$) of Kiribati in 1990 to that in 1991?
Your answer should be very brief. 2.12. What is the ratio of the Agriculture value added per worker (constant 2005 US$) of World in 1990 to that in 1992?
Your answer should be very brief. 0.91. What is the ratio of the Agriculture value added per worker (constant 2005 US$) of Colombia in 1990 to that in 1992?
Make the answer very short. 1.01. What is the ratio of the Agriculture value added per worker (constant 2005 US$) in Kiribati in 1990 to that in 1992?
Offer a terse response. 1.92. What is the ratio of the Agriculture value added per worker (constant 2005 US$) in World in 1990 to that in 1993?
Give a very brief answer. 0.93. What is the ratio of the Agriculture value added per worker (constant 2005 US$) of Colombia in 1990 to that in 1993?
Your response must be concise. 0.99. What is the ratio of the Agriculture value added per worker (constant 2005 US$) in Kiribati in 1990 to that in 1993?
Make the answer very short. 1.91. What is the ratio of the Agriculture value added per worker (constant 2005 US$) in World in 1991 to that in 1992?
Provide a short and direct response. 0.93. What is the ratio of the Agriculture value added per worker (constant 2005 US$) of Colombia in 1991 to that in 1992?
Your answer should be compact. 1.03. What is the ratio of the Agriculture value added per worker (constant 2005 US$) in Kiribati in 1991 to that in 1992?
Your answer should be compact. 0.91. What is the ratio of the Agriculture value added per worker (constant 2005 US$) in World in 1991 to that in 1993?
Ensure brevity in your answer.  0.95. What is the ratio of the Agriculture value added per worker (constant 2005 US$) of Colombia in 1991 to that in 1993?
Offer a terse response. 1.01. What is the ratio of the Agriculture value added per worker (constant 2005 US$) in Kiribati in 1991 to that in 1993?
Your answer should be compact. 0.9. What is the ratio of the Agriculture value added per worker (constant 2005 US$) of World in 1992 to that in 1993?
Provide a short and direct response. 1.02. What is the ratio of the Agriculture value added per worker (constant 2005 US$) of Colombia in 1992 to that in 1993?
Ensure brevity in your answer.  0.98. What is the difference between the highest and the second highest Agriculture value added per worker (constant 2005 US$) in World?
Offer a very short reply. 16.9. What is the difference between the highest and the second highest Agriculture value added per worker (constant 2005 US$) of Colombia?
Your response must be concise. 26.13. What is the difference between the highest and the second highest Agriculture value added per worker (constant 2005 US$) of Kiribati?
Offer a terse response. 1359.65. What is the difference between the highest and the lowest Agriculture value added per worker (constant 2005 US$) of World?
Provide a short and direct response. 160.89. What is the difference between the highest and the lowest Agriculture value added per worker (constant 2005 US$) in Colombia?
Offer a very short reply. 806.17. What is the difference between the highest and the lowest Agriculture value added per worker (constant 2005 US$) of Kiribati?
Your answer should be very brief. 5168.02. 